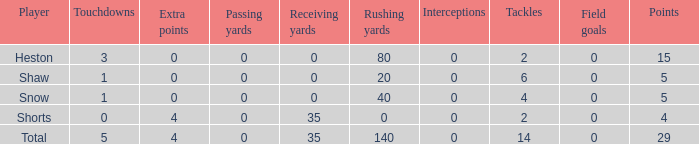What is the total number of field goals for a player that had less than 3 touchdowns, had 4 points, and had less than 4 extra points? 0.0. 